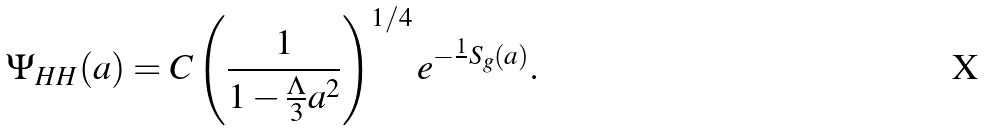Convert formula to latex. <formula><loc_0><loc_0><loc_500><loc_500>\Psi _ { H H } ( a ) = C \left ( \frac { 1 } { 1 - \frac { \Lambda } { 3 } a ^ { 2 } } \right ) ^ { 1 / 4 } e ^ { - \frac { 1 } { } S _ { g } ( a ) } .</formula> 